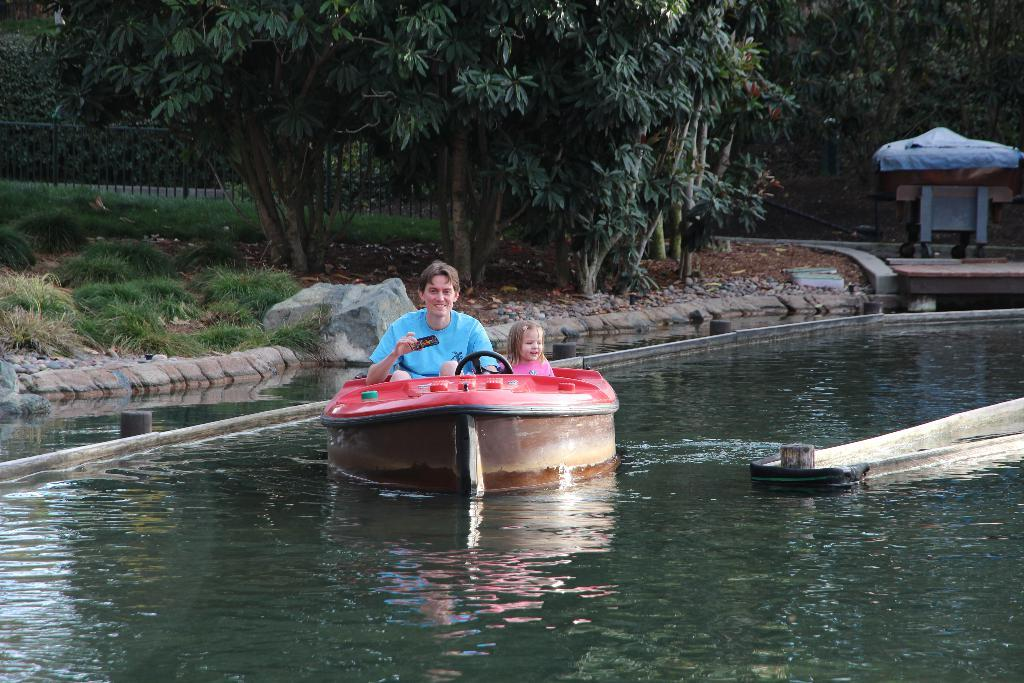What is the main subject in the center of the image? There is a boat in the center of the image. Where is the boat located? The boat is on the water. Who is in the boat? There is a man and a small girl in the boat. What can be seen in the background of the image? There is greenery and a shed in the background. What is the group's opinion on the pan in the image? There is no group or pan present in the image, so it is not possible to determine their opinion. 